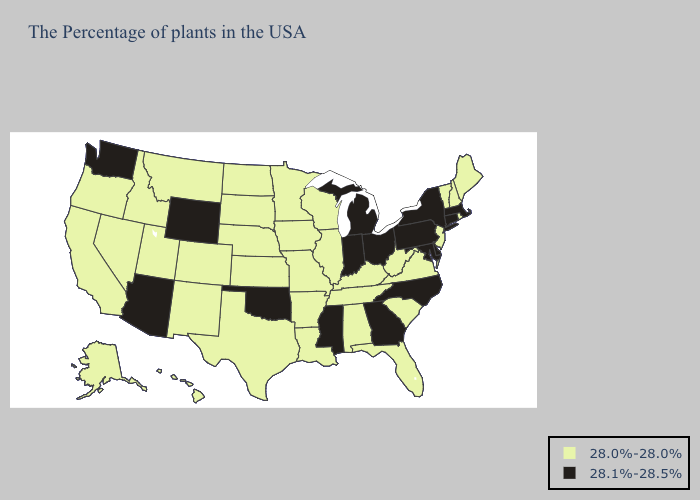What is the lowest value in states that border Ohio?
Write a very short answer. 28.0%-28.0%. Does New Jersey have the highest value in the Northeast?
Concise answer only. No. Does Wyoming have the lowest value in the USA?
Short answer required. No. Among the states that border Indiana , does Kentucky have the highest value?
Answer briefly. No. Name the states that have a value in the range 28.0%-28.0%?
Keep it brief. Maine, Rhode Island, New Hampshire, Vermont, New Jersey, Virginia, South Carolina, West Virginia, Florida, Kentucky, Alabama, Tennessee, Wisconsin, Illinois, Louisiana, Missouri, Arkansas, Minnesota, Iowa, Kansas, Nebraska, Texas, South Dakota, North Dakota, Colorado, New Mexico, Utah, Montana, Idaho, Nevada, California, Oregon, Alaska, Hawaii. Name the states that have a value in the range 28.1%-28.5%?
Short answer required. Massachusetts, Connecticut, New York, Delaware, Maryland, Pennsylvania, North Carolina, Ohio, Georgia, Michigan, Indiana, Mississippi, Oklahoma, Wyoming, Arizona, Washington. Among the states that border Oklahoma , which have the lowest value?
Be succinct. Missouri, Arkansas, Kansas, Texas, Colorado, New Mexico. Which states hav the highest value in the South?
Write a very short answer. Delaware, Maryland, North Carolina, Georgia, Mississippi, Oklahoma. What is the lowest value in the USA?
Write a very short answer. 28.0%-28.0%. Does Nebraska have a lower value than Ohio?
Quick response, please. Yes. What is the lowest value in states that border Delaware?
Short answer required. 28.0%-28.0%. What is the value of Delaware?
Answer briefly. 28.1%-28.5%. Does Nebraska have the same value as Kansas?
Answer briefly. Yes. What is the value of Colorado?
Concise answer only. 28.0%-28.0%. What is the value of Colorado?
Give a very brief answer. 28.0%-28.0%. 